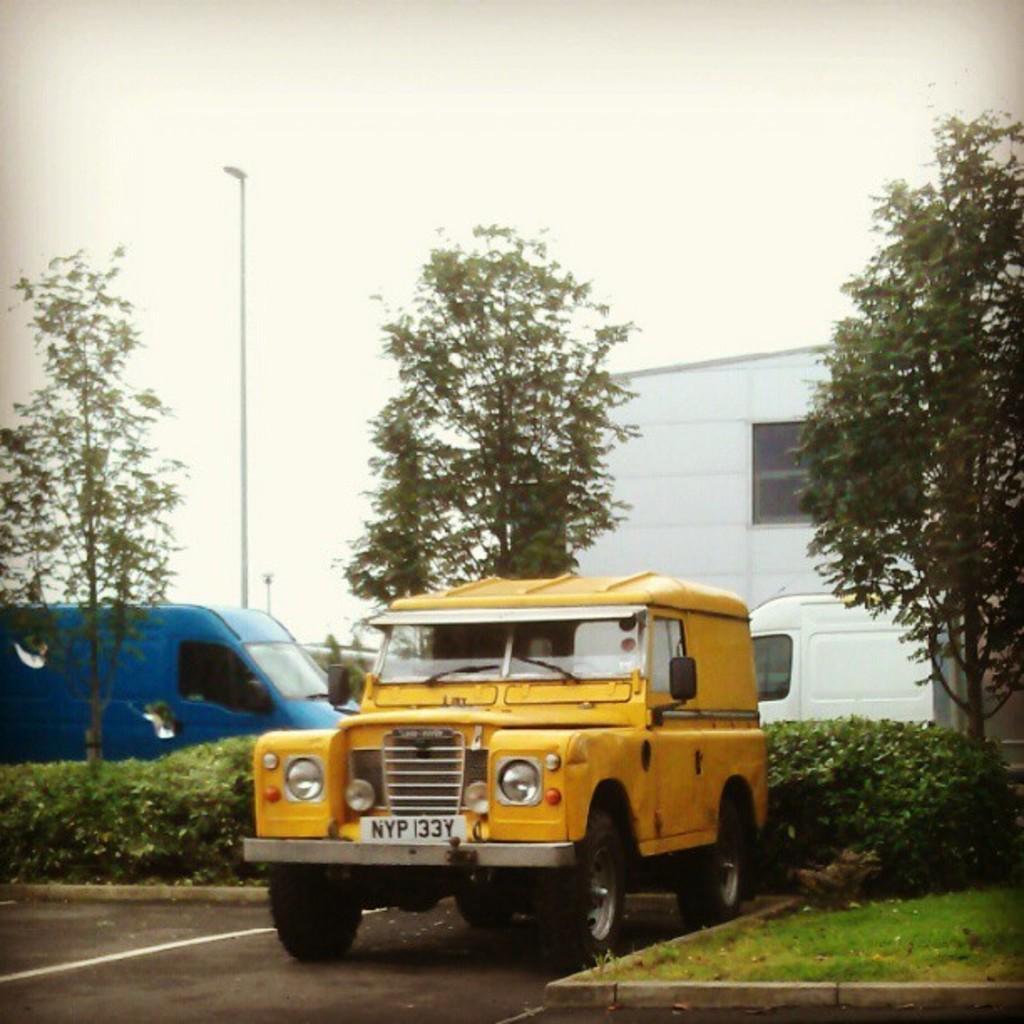Please provide a concise description of this image. In this image I can see a vehicle which is yellow in color on the road. I can see some grass, few plants, a blue colored vehicles, few trees, a white colored vehicle, a white colored building and the sky. 